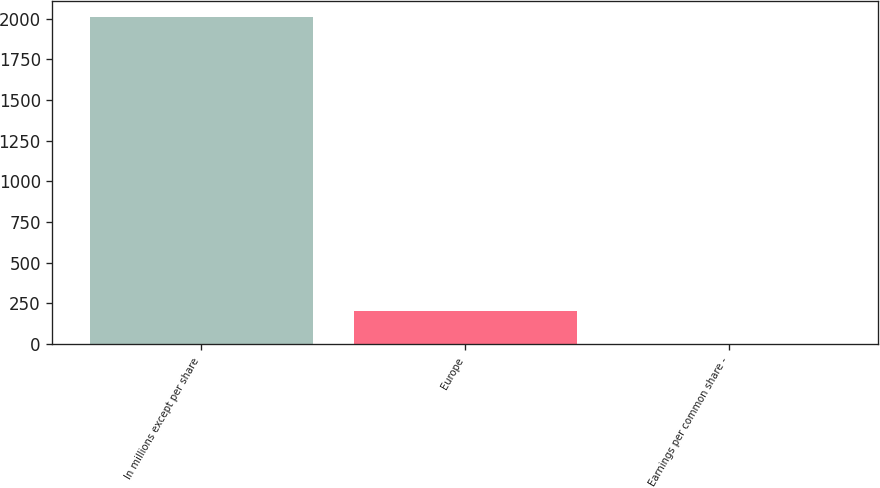Convert chart to OTSL. <chart><loc_0><loc_0><loc_500><loc_500><bar_chart><fcel>In millions except per share<fcel>Europe<fcel>Earnings per common share -<nl><fcel>2008<fcel>200.81<fcel>0.01<nl></chart> 